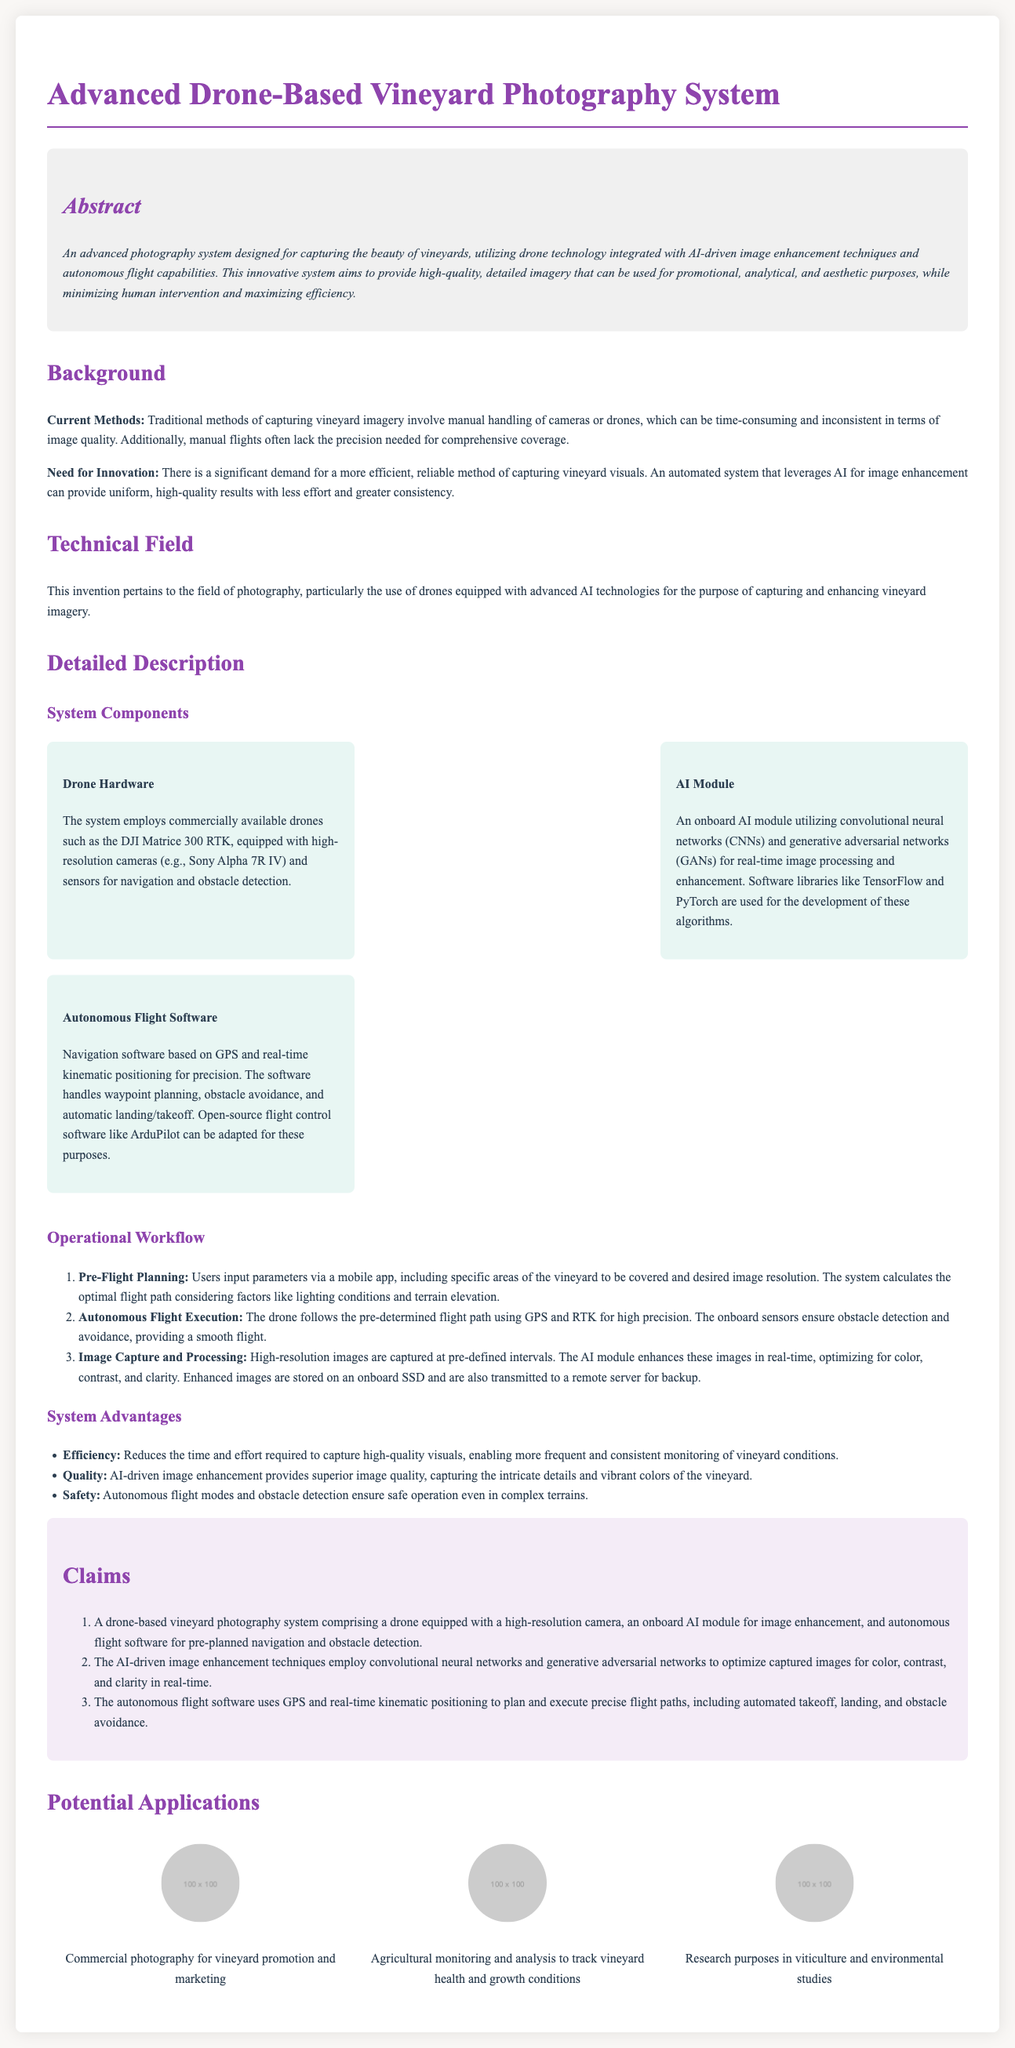What is the main purpose of the system? The system aims to provide high-quality, detailed imagery that can be used for promotional, analytical, and aesthetic purposes.
Answer: high-quality, detailed imagery Which drone model is mentioned in the system components? The document names a specific drone model used in the system.
Answer: DJI Matrice 300 RTK What type of networks are used in the AI module? The AI module employs specific types of networks for image processing.
Answer: convolutional neural networks and generative adversarial networks What is one of the key advantages of this system? The advantages section lists specific benefits of the system.
Answer: Efficiency What software can be adapted for the autonomous flight software? The document mentions software that can be used for flight control.
Answer: ArduPilot How many claims are outlined in the claims section? The number of claims is specified in the document.
Answer: three 